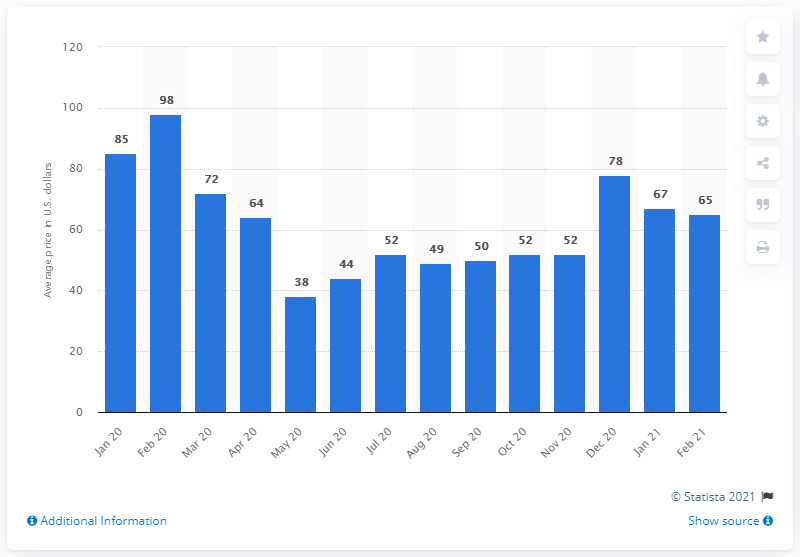List a handful of essential elements in this visual. The lowest rate in the entire year was 38.. 